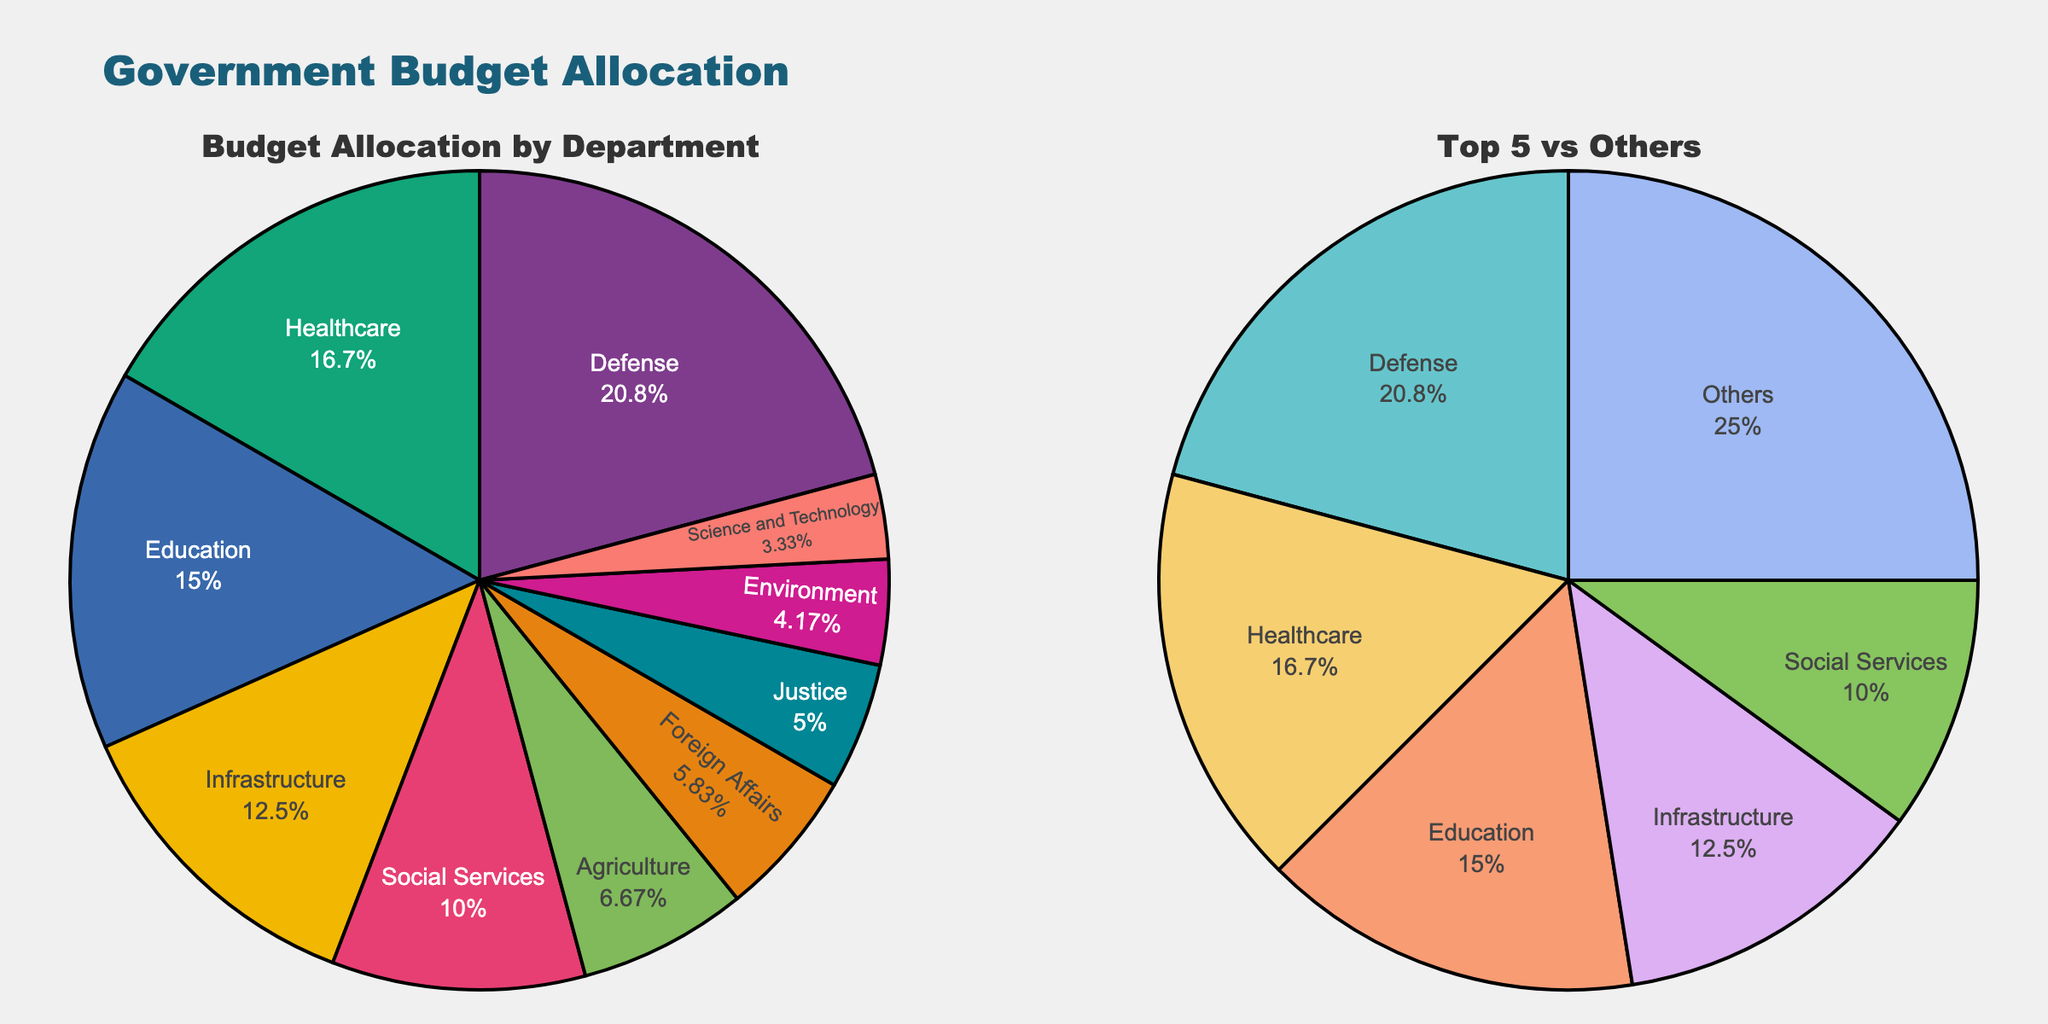Which department receives the highest budget allocation? The pie charts show that 'Defense' has the largest slice in both charts, indicating it has the highest budget allocation.
Answer: Defense What's the title of the figure? The title of the figure is prominently placed at the top. It reads, "Government Budget Allocation."
Answer: Government Budget Allocation How many departments have a budget allocation less than $100 million? By observing the pie chart, it can be seen that 'Agriculture', 'Foreign Affairs', 'Justice', 'Environment', and 'Science and Technology' have smaller slices, each representing less than $100 million.
Answer: Five What is the combined budget allocation of the 'Education' and 'Healthcare' departments? According to the slices in the pie chart, 'Education' has $180 million, and 'Healthcare' has $200 million. Their combined budget is $180 million + $200 million.
Answer: $380 million Which category has a larger budget, 'Agriculture' or 'Environment'? The 'Agriculture' slice is larger than the 'Environment' slice in the pie charts, indicating a bigger budget.
Answer: Agriculture What percentage of the budget is allocated to 'Infrastructure'? In the pie chart, the slice for 'Infrastructure' shows its percentage. It's one of the larger slices after Defense, Education, and Healthcare.
Answer: 14.8% Are there more than 5 departments with budget allocations less than the 'Healthcare' department? By comparing the sizes of the slices, it is clear that more than five departments have smaller slices than Healthcare's, indicating lower budgets.
Answer: Yes What is the total budget allocation for the 'Top 5' departments? Summing the budget amounts of the top 5 departments: Defense ($250M), Education ($180M), Healthcare ($200M), Infrastructure ($150M), and Social Services ($120M) gives the total.
Answer: $900 million How is the budget distributed between the 'Top 5 departments' and 'Others' according to the second pie chart? The pie chart for 'Top 5 vs. Others' shows the slice for 'Top 5 departments' and another slice for 'Others.' 'Top 5 departments' occupy the majority, indicating a larger share.
Answer: Top 5 have a larger share What is the percentage difference between the budget allocation in 'Defense' and 'Environment'? The 'Defense' slice is significantly larger than the 'Environment' slice. The exact percentages can be found directly on the chart slices.
Answer: 38.3% 